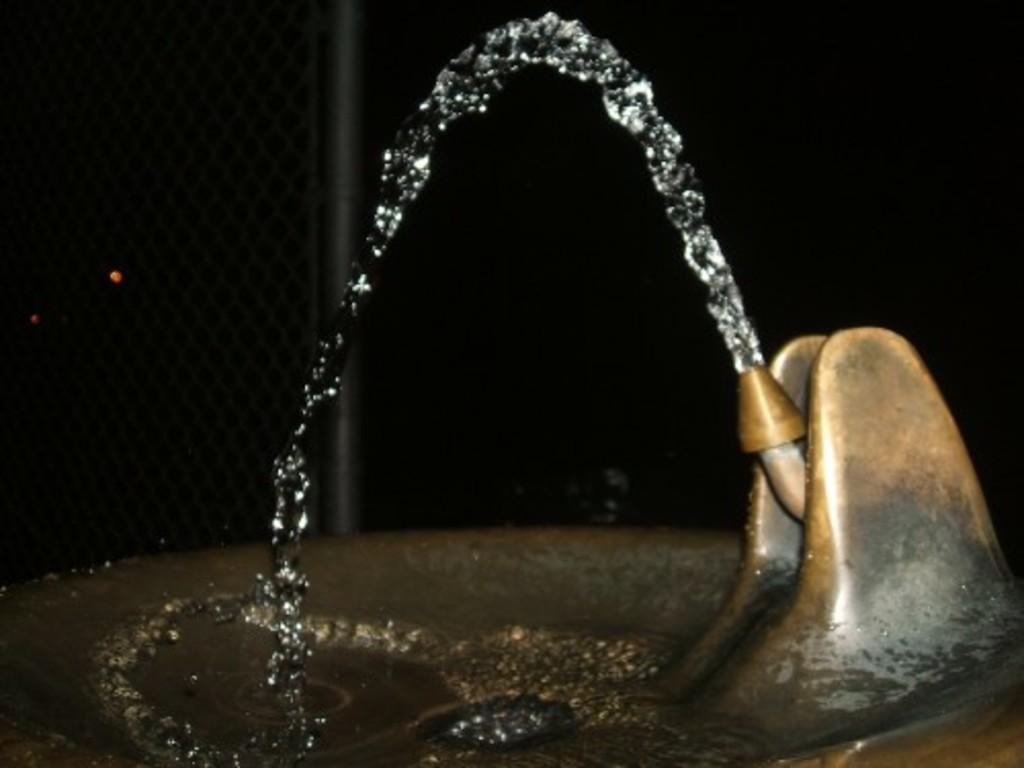Could you give a brief overview of what you see in this image? Here we can see sink with tap and water and we can see mesh with rod. 